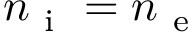<formula> <loc_0><loc_0><loc_500><loc_500>n _ { i } = n _ { e }</formula> 